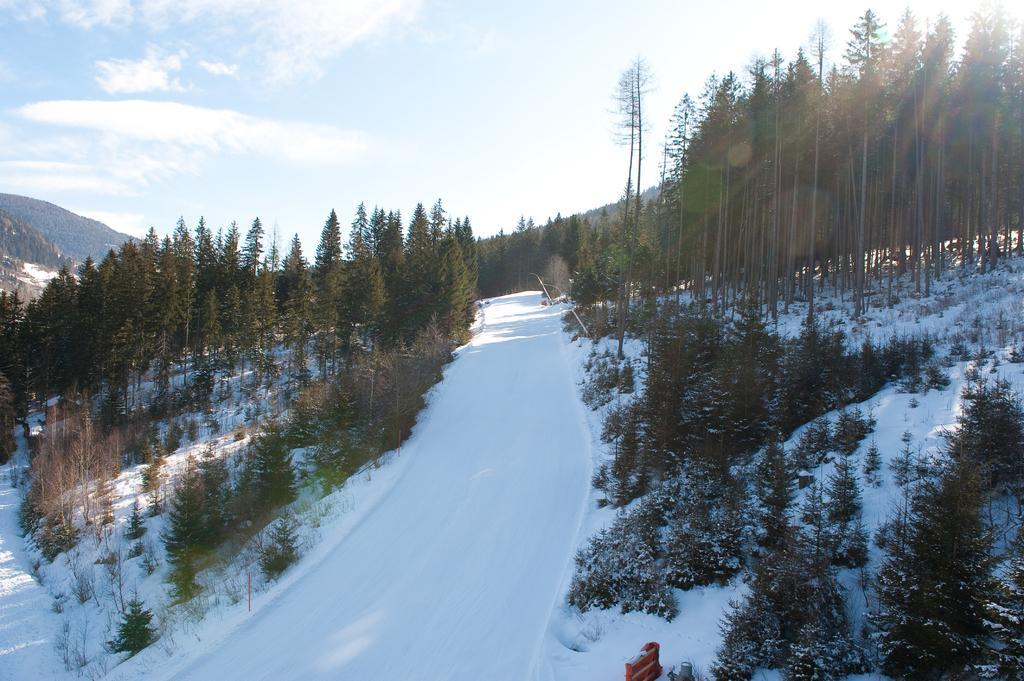In one or two sentences, can you explain what this image depicts? This is an outside view. At the bottom, I can see the snow and there is a path. On both sides there are many plants and trees. On the left side there is a hill. At the top of the image I can see the sky and clouds. 